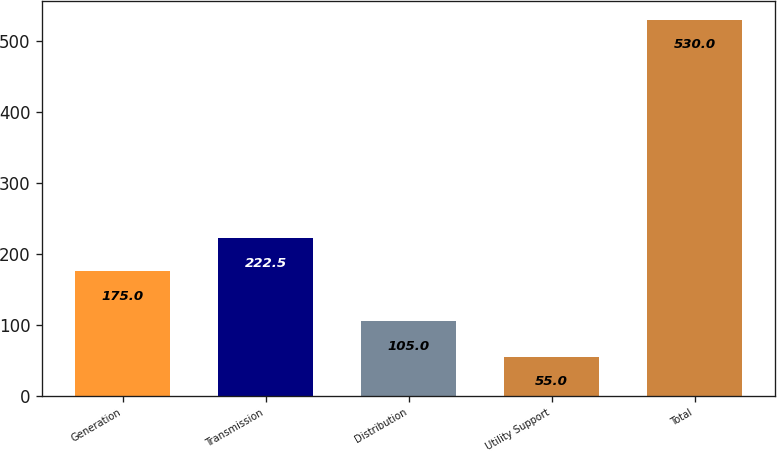<chart> <loc_0><loc_0><loc_500><loc_500><bar_chart><fcel>Generation<fcel>Transmission<fcel>Distribution<fcel>Utility Support<fcel>Total<nl><fcel>175<fcel>222.5<fcel>105<fcel>55<fcel>530<nl></chart> 